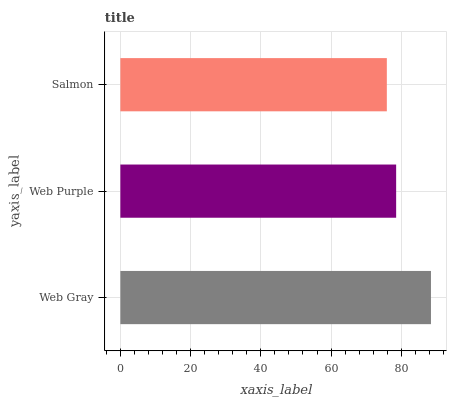Is Salmon the minimum?
Answer yes or no. Yes. Is Web Gray the maximum?
Answer yes or no. Yes. Is Web Purple the minimum?
Answer yes or no. No. Is Web Purple the maximum?
Answer yes or no. No. Is Web Gray greater than Web Purple?
Answer yes or no. Yes. Is Web Purple less than Web Gray?
Answer yes or no. Yes. Is Web Purple greater than Web Gray?
Answer yes or no. No. Is Web Gray less than Web Purple?
Answer yes or no. No. Is Web Purple the high median?
Answer yes or no. Yes. Is Web Purple the low median?
Answer yes or no. Yes. Is Salmon the high median?
Answer yes or no. No. Is Salmon the low median?
Answer yes or no. No. 